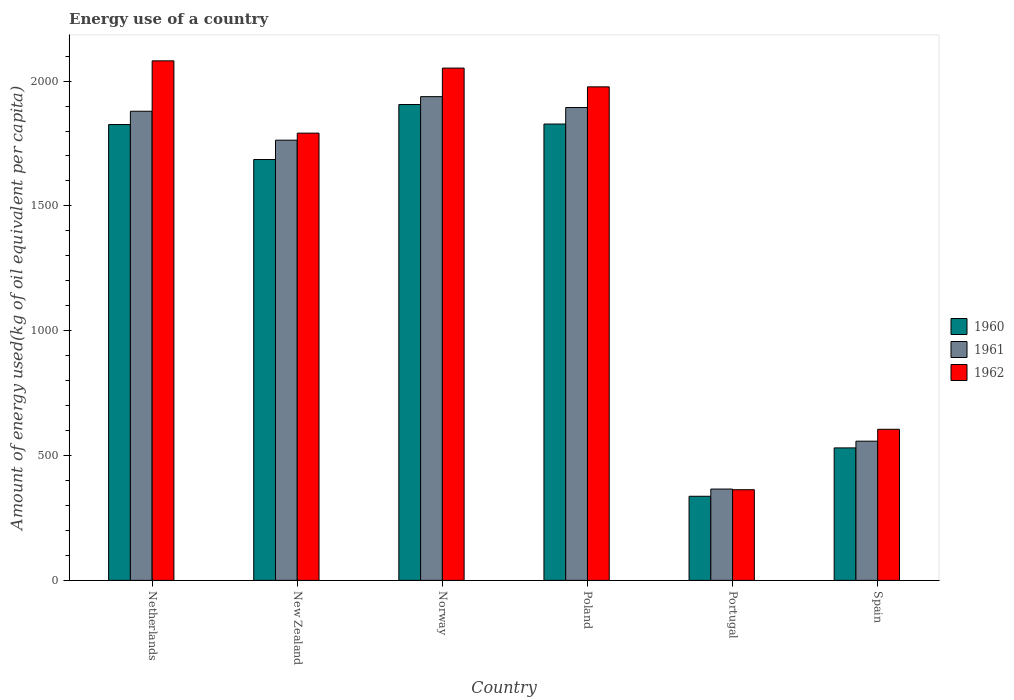Are the number of bars on each tick of the X-axis equal?
Your answer should be compact. Yes. How many bars are there on the 4th tick from the left?
Your response must be concise. 3. How many bars are there on the 1st tick from the right?
Offer a terse response. 3. What is the label of the 6th group of bars from the left?
Your answer should be very brief. Spain. What is the amount of energy used in in 1961 in Norway?
Keep it short and to the point. 1937.64. Across all countries, what is the maximum amount of energy used in in 1962?
Your answer should be compact. 2081.01. Across all countries, what is the minimum amount of energy used in in 1961?
Give a very brief answer. 365.84. In which country was the amount of energy used in in 1961 maximum?
Provide a succinct answer. Norway. In which country was the amount of energy used in in 1962 minimum?
Provide a short and direct response. Portugal. What is the total amount of energy used in in 1960 in the graph?
Offer a very short reply. 8113.41. What is the difference between the amount of energy used in in 1961 in New Zealand and that in Norway?
Provide a short and direct response. -174.38. What is the difference between the amount of energy used in in 1962 in New Zealand and the amount of energy used in in 1961 in Portugal?
Offer a very short reply. 1425.62. What is the average amount of energy used in in 1962 per country?
Make the answer very short. 1478.3. What is the difference between the amount of energy used in of/in 1962 and amount of energy used in of/in 1960 in Norway?
Offer a very short reply. 145.88. What is the ratio of the amount of energy used in in 1960 in New Zealand to that in Spain?
Offer a terse response. 3.18. Is the amount of energy used in in 1961 in Portugal less than that in Spain?
Your answer should be compact. Yes. Is the difference between the amount of energy used in in 1962 in Netherlands and Norway greater than the difference between the amount of energy used in in 1960 in Netherlands and Norway?
Provide a succinct answer. Yes. What is the difference between the highest and the second highest amount of energy used in in 1962?
Give a very brief answer. -104.15. What is the difference between the highest and the lowest amount of energy used in in 1962?
Provide a short and direct response. 1717.85. What does the 2nd bar from the right in Spain represents?
Your answer should be compact. 1961. Is it the case that in every country, the sum of the amount of energy used in in 1962 and amount of energy used in in 1961 is greater than the amount of energy used in in 1960?
Make the answer very short. Yes. What is the difference between two consecutive major ticks on the Y-axis?
Keep it short and to the point. 500. Does the graph contain any zero values?
Your answer should be very brief. No. How many legend labels are there?
Your response must be concise. 3. What is the title of the graph?
Provide a short and direct response. Energy use of a country. Does "1987" appear as one of the legend labels in the graph?
Keep it short and to the point. No. What is the label or title of the X-axis?
Make the answer very short. Country. What is the label or title of the Y-axis?
Your answer should be compact. Amount of energy used(kg of oil equivalent per capita). What is the Amount of energy used(kg of oil equivalent per capita) in 1960 in Netherlands?
Keep it short and to the point. 1825.93. What is the Amount of energy used(kg of oil equivalent per capita) in 1961 in Netherlands?
Offer a very short reply. 1879.15. What is the Amount of energy used(kg of oil equivalent per capita) in 1962 in Netherlands?
Provide a succinct answer. 2081.01. What is the Amount of energy used(kg of oil equivalent per capita) in 1960 in New Zealand?
Provide a succinct answer. 1685.79. What is the Amount of energy used(kg of oil equivalent per capita) of 1961 in New Zealand?
Provide a succinct answer. 1763.26. What is the Amount of energy used(kg of oil equivalent per capita) in 1962 in New Zealand?
Provide a short and direct response. 1791.46. What is the Amount of energy used(kg of oil equivalent per capita) of 1960 in Norway?
Ensure brevity in your answer.  1906.17. What is the Amount of energy used(kg of oil equivalent per capita) in 1961 in Norway?
Ensure brevity in your answer.  1937.64. What is the Amount of energy used(kg of oil equivalent per capita) in 1962 in Norway?
Your answer should be very brief. 2052.05. What is the Amount of energy used(kg of oil equivalent per capita) in 1960 in Poland?
Provide a short and direct response. 1827.94. What is the Amount of energy used(kg of oil equivalent per capita) of 1961 in Poland?
Ensure brevity in your answer.  1894.06. What is the Amount of energy used(kg of oil equivalent per capita) in 1962 in Poland?
Offer a terse response. 1976.86. What is the Amount of energy used(kg of oil equivalent per capita) in 1960 in Portugal?
Provide a short and direct response. 336.91. What is the Amount of energy used(kg of oil equivalent per capita) of 1961 in Portugal?
Your answer should be very brief. 365.84. What is the Amount of energy used(kg of oil equivalent per capita) of 1962 in Portugal?
Make the answer very short. 363.16. What is the Amount of energy used(kg of oil equivalent per capita) of 1960 in Spain?
Give a very brief answer. 530.66. What is the Amount of energy used(kg of oil equivalent per capita) in 1961 in Spain?
Offer a terse response. 557.6. What is the Amount of energy used(kg of oil equivalent per capita) in 1962 in Spain?
Your answer should be very brief. 605.22. Across all countries, what is the maximum Amount of energy used(kg of oil equivalent per capita) in 1960?
Offer a terse response. 1906.17. Across all countries, what is the maximum Amount of energy used(kg of oil equivalent per capita) in 1961?
Ensure brevity in your answer.  1937.64. Across all countries, what is the maximum Amount of energy used(kg of oil equivalent per capita) in 1962?
Make the answer very short. 2081.01. Across all countries, what is the minimum Amount of energy used(kg of oil equivalent per capita) in 1960?
Make the answer very short. 336.91. Across all countries, what is the minimum Amount of energy used(kg of oil equivalent per capita) in 1961?
Give a very brief answer. 365.84. Across all countries, what is the minimum Amount of energy used(kg of oil equivalent per capita) of 1962?
Give a very brief answer. 363.16. What is the total Amount of energy used(kg of oil equivalent per capita) of 1960 in the graph?
Offer a very short reply. 8113.41. What is the total Amount of energy used(kg of oil equivalent per capita) of 1961 in the graph?
Provide a succinct answer. 8397.55. What is the total Amount of energy used(kg of oil equivalent per capita) in 1962 in the graph?
Provide a short and direct response. 8869.77. What is the difference between the Amount of energy used(kg of oil equivalent per capita) of 1960 in Netherlands and that in New Zealand?
Offer a very short reply. 140.15. What is the difference between the Amount of energy used(kg of oil equivalent per capita) of 1961 in Netherlands and that in New Zealand?
Provide a succinct answer. 115.89. What is the difference between the Amount of energy used(kg of oil equivalent per capita) of 1962 in Netherlands and that in New Zealand?
Your answer should be compact. 289.55. What is the difference between the Amount of energy used(kg of oil equivalent per capita) in 1960 in Netherlands and that in Norway?
Provide a short and direct response. -80.24. What is the difference between the Amount of energy used(kg of oil equivalent per capita) of 1961 in Netherlands and that in Norway?
Provide a succinct answer. -58.49. What is the difference between the Amount of energy used(kg of oil equivalent per capita) in 1962 in Netherlands and that in Norway?
Your response must be concise. 28.96. What is the difference between the Amount of energy used(kg of oil equivalent per capita) of 1960 in Netherlands and that in Poland?
Ensure brevity in your answer.  -2. What is the difference between the Amount of energy used(kg of oil equivalent per capita) of 1961 in Netherlands and that in Poland?
Your response must be concise. -14.91. What is the difference between the Amount of energy used(kg of oil equivalent per capita) of 1962 in Netherlands and that in Poland?
Offer a very short reply. 104.15. What is the difference between the Amount of energy used(kg of oil equivalent per capita) of 1960 in Netherlands and that in Portugal?
Keep it short and to the point. 1489.02. What is the difference between the Amount of energy used(kg of oil equivalent per capita) of 1961 in Netherlands and that in Portugal?
Make the answer very short. 1513.31. What is the difference between the Amount of energy used(kg of oil equivalent per capita) in 1962 in Netherlands and that in Portugal?
Ensure brevity in your answer.  1717.85. What is the difference between the Amount of energy used(kg of oil equivalent per capita) in 1960 in Netherlands and that in Spain?
Offer a terse response. 1295.27. What is the difference between the Amount of energy used(kg of oil equivalent per capita) of 1961 in Netherlands and that in Spain?
Your response must be concise. 1321.55. What is the difference between the Amount of energy used(kg of oil equivalent per capita) of 1962 in Netherlands and that in Spain?
Make the answer very short. 1475.79. What is the difference between the Amount of energy used(kg of oil equivalent per capita) of 1960 in New Zealand and that in Norway?
Make the answer very short. -220.39. What is the difference between the Amount of energy used(kg of oil equivalent per capita) of 1961 in New Zealand and that in Norway?
Give a very brief answer. -174.38. What is the difference between the Amount of energy used(kg of oil equivalent per capita) of 1962 in New Zealand and that in Norway?
Ensure brevity in your answer.  -260.59. What is the difference between the Amount of energy used(kg of oil equivalent per capita) in 1960 in New Zealand and that in Poland?
Provide a short and direct response. -142.15. What is the difference between the Amount of energy used(kg of oil equivalent per capita) in 1961 in New Zealand and that in Poland?
Provide a short and direct response. -130.8. What is the difference between the Amount of energy used(kg of oil equivalent per capita) of 1962 in New Zealand and that in Poland?
Make the answer very short. -185.4. What is the difference between the Amount of energy used(kg of oil equivalent per capita) of 1960 in New Zealand and that in Portugal?
Keep it short and to the point. 1348.87. What is the difference between the Amount of energy used(kg of oil equivalent per capita) in 1961 in New Zealand and that in Portugal?
Give a very brief answer. 1397.42. What is the difference between the Amount of energy used(kg of oil equivalent per capita) of 1962 in New Zealand and that in Portugal?
Ensure brevity in your answer.  1428.3. What is the difference between the Amount of energy used(kg of oil equivalent per capita) of 1960 in New Zealand and that in Spain?
Offer a terse response. 1155.12. What is the difference between the Amount of energy used(kg of oil equivalent per capita) of 1961 in New Zealand and that in Spain?
Provide a short and direct response. 1205.66. What is the difference between the Amount of energy used(kg of oil equivalent per capita) of 1962 in New Zealand and that in Spain?
Your response must be concise. 1186.24. What is the difference between the Amount of energy used(kg of oil equivalent per capita) in 1960 in Norway and that in Poland?
Ensure brevity in your answer.  78.24. What is the difference between the Amount of energy used(kg of oil equivalent per capita) in 1961 in Norway and that in Poland?
Provide a succinct answer. 43.59. What is the difference between the Amount of energy used(kg of oil equivalent per capita) in 1962 in Norway and that in Poland?
Give a very brief answer. 75.19. What is the difference between the Amount of energy used(kg of oil equivalent per capita) of 1960 in Norway and that in Portugal?
Offer a very short reply. 1569.26. What is the difference between the Amount of energy used(kg of oil equivalent per capita) of 1961 in Norway and that in Portugal?
Provide a succinct answer. 1571.8. What is the difference between the Amount of energy used(kg of oil equivalent per capita) in 1962 in Norway and that in Portugal?
Provide a short and direct response. 1688.89. What is the difference between the Amount of energy used(kg of oil equivalent per capita) in 1960 in Norway and that in Spain?
Make the answer very short. 1375.51. What is the difference between the Amount of energy used(kg of oil equivalent per capita) in 1961 in Norway and that in Spain?
Offer a very short reply. 1380.05. What is the difference between the Amount of energy used(kg of oil equivalent per capita) of 1962 in Norway and that in Spain?
Your answer should be very brief. 1446.83. What is the difference between the Amount of energy used(kg of oil equivalent per capita) in 1960 in Poland and that in Portugal?
Provide a short and direct response. 1491.02. What is the difference between the Amount of energy used(kg of oil equivalent per capita) in 1961 in Poland and that in Portugal?
Your answer should be very brief. 1528.22. What is the difference between the Amount of energy used(kg of oil equivalent per capita) of 1962 in Poland and that in Portugal?
Give a very brief answer. 1613.7. What is the difference between the Amount of energy used(kg of oil equivalent per capita) of 1960 in Poland and that in Spain?
Provide a short and direct response. 1297.27. What is the difference between the Amount of energy used(kg of oil equivalent per capita) in 1961 in Poland and that in Spain?
Provide a short and direct response. 1336.46. What is the difference between the Amount of energy used(kg of oil equivalent per capita) of 1962 in Poland and that in Spain?
Provide a succinct answer. 1371.64. What is the difference between the Amount of energy used(kg of oil equivalent per capita) of 1960 in Portugal and that in Spain?
Your response must be concise. -193.75. What is the difference between the Amount of energy used(kg of oil equivalent per capita) of 1961 in Portugal and that in Spain?
Your answer should be compact. -191.76. What is the difference between the Amount of energy used(kg of oil equivalent per capita) in 1962 in Portugal and that in Spain?
Keep it short and to the point. -242.06. What is the difference between the Amount of energy used(kg of oil equivalent per capita) of 1960 in Netherlands and the Amount of energy used(kg of oil equivalent per capita) of 1961 in New Zealand?
Keep it short and to the point. 62.67. What is the difference between the Amount of energy used(kg of oil equivalent per capita) of 1960 in Netherlands and the Amount of energy used(kg of oil equivalent per capita) of 1962 in New Zealand?
Your answer should be very brief. 34.47. What is the difference between the Amount of energy used(kg of oil equivalent per capita) in 1961 in Netherlands and the Amount of energy used(kg of oil equivalent per capita) in 1962 in New Zealand?
Offer a terse response. 87.69. What is the difference between the Amount of energy used(kg of oil equivalent per capita) of 1960 in Netherlands and the Amount of energy used(kg of oil equivalent per capita) of 1961 in Norway?
Give a very brief answer. -111.71. What is the difference between the Amount of energy used(kg of oil equivalent per capita) in 1960 in Netherlands and the Amount of energy used(kg of oil equivalent per capita) in 1962 in Norway?
Ensure brevity in your answer.  -226.12. What is the difference between the Amount of energy used(kg of oil equivalent per capita) in 1961 in Netherlands and the Amount of energy used(kg of oil equivalent per capita) in 1962 in Norway?
Your response must be concise. -172.9. What is the difference between the Amount of energy used(kg of oil equivalent per capita) of 1960 in Netherlands and the Amount of energy used(kg of oil equivalent per capita) of 1961 in Poland?
Provide a succinct answer. -68.12. What is the difference between the Amount of energy used(kg of oil equivalent per capita) of 1960 in Netherlands and the Amount of energy used(kg of oil equivalent per capita) of 1962 in Poland?
Make the answer very short. -150.93. What is the difference between the Amount of energy used(kg of oil equivalent per capita) in 1961 in Netherlands and the Amount of energy used(kg of oil equivalent per capita) in 1962 in Poland?
Your answer should be very brief. -97.71. What is the difference between the Amount of energy used(kg of oil equivalent per capita) of 1960 in Netherlands and the Amount of energy used(kg of oil equivalent per capita) of 1961 in Portugal?
Keep it short and to the point. 1460.09. What is the difference between the Amount of energy used(kg of oil equivalent per capita) of 1960 in Netherlands and the Amount of energy used(kg of oil equivalent per capita) of 1962 in Portugal?
Provide a succinct answer. 1462.77. What is the difference between the Amount of energy used(kg of oil equivalent per capita) of 1961 in Netherlands and the Amount of energy used(kg of oil equivalent per capita) of 1962 in Portugal?
Your answer should be compact. 1515.99. What is the difference between the Amount of energy used(kg of oil equivalent per capita) in 1960 in Netherlands and the Amount of energy used(kg of oil equivalent per capita) in 1961 in Spain?
Ensure brevity in your answer.  1268.34. What is the difference between the Amount of energy used(kg of oil equivalent per capita) in 1960 in Netherlands and the Amount of energy used(kg of oil equivalent per capita) in 1962 in Spain?
Make the answer very short. 1220.71. What is the difference between the Amount of energy used(kg of oil equivalent per capita) in 1961 in Netherlands and the Amount of energy used(kg of oil equivalent per capita) in 1962 in Spain?
Provide a short and direct response. 1273.93. What is the difference between the Amount of energy used(kg of oil equivalent per capita) of 1960 in New Zealand and the Amount of energy used(kg of oil equivalent per capita) of 1961 in Norway?
Your answer should be very brief. -251.86. What is the difference between the Amount of energy used(kg of oil equivalent per capita) of 1960 in New Zealand and the Amount of energy used(kg of oil equivalent per capita) of 1962 in Norway?
Your answer should be compact. -366.27. What is the difference between the Amount of energy used(kg of oil equivalent per capita) in 1961 in New Zealand and the Amount of energy used(kg of oil equivalent per capita) in 1962 in Norway?
Your answer should be compact. -288.79. What is the difference between the Amount of energy used(kg of oil equivalent per capita) of 1960 in New Zealand and the Amount of energy used(kg of oil equivalent per capita) of 1961 in Poland?
Your answer should be compact. -208.27. What is the difference between the Amount of energy used(kg of oil equivalent per capita) of 1960 in New Zealand and the Amount of energy used(kg of oil equivalent per capita) of 1962 in Poland?
Ensure brevity in your answer.  -291.07. What is the difference between the Amount of energy used(kg of oil equivalent per capita) of 1961 in New Zealand and the Amount of energy used(kg of oil equivalent per capita) of 1962 in Poland?
Offer a very short reply. -213.6. What is the difference between the Amount of energy used(kg of oil equivalent per capita) of 1960 in New Zealand and the Amount of energy used(kg of oil equivalent per capita) of 1961 in Portugal?
Your response must be concise. 1319.95. What is the difference between the Amount of energy used(kg of oil equivalent per capita) of 1960 in New Zealand and the Amount of energy used(kg of oil equivalent per capita) of 1962 in Portugal?
Make the answer very short. 1322.62. What is the difference between the Amount of energy used(kg of oil equivalent per capita) of 1961 in New Zealand and the Amount of energy used(kg of oil equivalent per capita) of 1962 in Portugal?
Offer a very short reply. 1400.1. What is the difference between the Amount of energy used(kg of oil equivalent per capita) of 1960 in New Zealand and the Amount of energy used(kg of oil equivalent per capita) of 1961 in Spain?
Your answer should be very brief. 1128.19. What is the difference between the Amount of energy used(kg of oil equivalent per capita) of 1960 in New Zealand and the Amount of energy used(kg of oil equivalent per capita) of 1962 in Spain?
Your answer should be very brief. 1080.56. What is the difference between the Amount of energy used(kg of oil equivalent per capita) in 1961 in New Zealand and the Amount of energy used(kg of oil equivalent per capita) in 1962 in Spain?
Provide a short and direct response. 1158.04. What is the difference between the Amount of energy used(kg of oil equivalent per capita) of 1960 in Norway and the Amount of energy used(kg of oil equivalent per capita) of 1961 in Poland?
Give a very brief answer. 12.12. What is the difference between the Amount of energy used(kg of oil equivalent per capita) of 1960 in Norway and the Amount of energy used(kg of oil equivalent per capita) of 1962 in Poland?
Give a very brief answer. -70.68. What is the difference between the Amount of energy used(kg of oil equivalent per capita) in 1961 in Norway and the Amount of energy used(kg of oil equivalent per capita) in 1962 in Poland?
Provide a short and direct response. -39.22. What is the difference between the Amount of energy used(kg of oil equivalent per capita) in 1960 in Norway and the Amount of energy used(kg of oil equivalent per capita) in 1961 in Portugal?
Offer a very short reply. 1540.33. What is the difference between the Amount of energy used(kg of oil equivalent per capita) of 1960 in Norway and the Amount of energy used(kg of oil equivalent per capita) of 1962 in Portugal?
Keep it short and to the point. 1543.01. What is the difference between the Amount of energy used(kg of oil equivalent per capita) of 1961 in Norway and the Amount of energy used(kg of oil equivalent per capita) of 1962 in Portugal?
Provide a short and direct response. 1574.48. What is the difference between the Amount of energy used(kg of oil equivalent per capita) of 1960 in Norway and the Amount of energy used(kg of oil equivalent per capita) of 1961 in Spain?
Your answer should be compact. 1348.58. What is the difference between the Amount of energy used(kg of oil equivalent per capita) in 1960 in Norway and the Amount of energy used(kg of oil equivalent per capita) in 1962 in Spain?
Keep it short and to the point. 1300.95. What is the difference between the Amount of energy used(kg of oil equivalent per capita) in 1961 in Norway and the Amount of energy used(kg of oil equivalent per capita) in 1962 in Spain?
Give a very brief answer. 1332.42. What is the difference between the Amount of energy used(kg of oil equivalent per capita) in 1960 in Poland and the Amount of energy used(kg of oil equivalent per capita) in 1961 in Portugal?
Provide a short and direct response. 1462.1. What is the difference between the Amount of energy used(kg of oil equivalent per capita) in 1960 in Poland and the Amount of energy used(kg of oil equivalent per capita) in 1962 in Portugal?
Offer a very short reply. 1464.77. What is the difference between the Amount of energy used(kg of oil equivalent per capita) of 1961 in Poland and the Amount of energy used(kg of oil equivalent per capita) of 1962 in Portugal?
Provide a succinct answer. 1530.89. What is the difference between the Amount of energy used(kg of oil equivalent per capita) of 1960 in Poland and the Amount of energy used(kg of oil equivalent per capita) of 1961 in Spain?
Offer a terse response. 1270.34. What is the difference between the Amount of energy used(kg of oil equivalent per capita) in 1960 in Poland and the Amount of energy used(kg of oil equivalent per capita) in 1962 in Spain?
Your answer should be compact. 1222.71. What is the difference between the Amount of energy used(kg of oil equivalent per capita) of 1961 in Poland and the Amount of energy used(kg of oil equivalent per capita) of 1962 in Spain?
Your response must be concise. 1288.83. What is the difference between the Amount of energy used(kg of oil equivalent per capita) in 1960 in Portugal and the Amount of energy used(kg of oil equivalent per capita) in 1961 in Spain?
Ensure brevity in your answer.  -220.69. What is the difference between the Amount of energy used(kg of oil equivalent per capita) in 1960 in Portugal and the Amount of energy used(kg of oil equivalent per capita) in 1962 in Spain?
Provide a short and direct response. -268.31. What is the difference between the Amount of energy used(kg of oil equivalent per capita) of 1961 in Portugal and the Amount of energy used(kg of oil equivalent per capita) of 1962 in Spain?
Ensure brevity in your answer.  -239.38. What is the average Amount of energy used(kg of oil equivalent per capita) in 1960 per country?
Keep it short and to the point. 1352.24. What is the average Amount of energy used(kg of oil equivalent per capita) in 1961 per country?
Your answer should be very brief. 1399.59. What is the average Amount of energy used(kg of oil equivalent per capita) of 1962 per country?
Provide a succinct answer. 1478.3. What is the difference between the Amount of energy used(kg of oil equivalent per capita) of 1960 and Amount of energy used(kg of oil equivalent per capita) of 1961 in Netherlands?
Give a very brief answer. -53.22. What is the difference between the Amount of energy used(kg of oil equivalent per capita) of 1960 and Amount of energy used(kg of oil equivalent per capita) of 1962 in Netherlands?
Give a very brief answer. -255.08. What is the difference between the Amount of energy used(kg of oil equivalent per capita) in 1961 and Amount of energy used(kg of oil equivalent per capita) in 1962 in Netherlands?
Provide a short and direct response. -201.86. What is the difference between the Amount of energy used(kg of oil equivalent per capita) in 1960 and Amount of energy used(kg of oil equivalent per capita) in 1961 in New Zealand?
Give a very brief answer. -77.47. What is the difference between the Amount of energy used(kg of oil equivalent per capita) of 1960 and Amount of energy used(kg of oil equivalent per capita) of 1962 in New Zealand?
Your response must be concise. -105.67. What is the difference between the Amount of energy used(kg of oil equivalent per capita) in 1961 and Amount of energy used(kg of oil equivalent per capita) in 1962 in New Zealand?
Give a very brief answer. -28.2. What is the difference between the Amount of energy used(kg of oil equivalent per capita) of 1960 and Amount of energy used(kg of oil equivalent per capita) of 1961 in Norway?
Keep it short and to the point. -31.47. What is the difference between the Amount of energy used(kg of oil equivalent per capita) in 1960 and Amount of energy used(kg of oil equivalent per capita) in 1962 in Norway?
Give a very brief answer. -145.88. What is the difference between the Amount of energy used(kg of oil equivalent per capita) of 1961 and Amount of energy used(kg of oil equivalent per capita) of 1962 in Norway?
Your response must be concise. -114.41. What is the difference between the Amount of energy used(kg of oil equivalent per capita) of 1960 and Amount of energy used(kg of oil equivalent per capita) of 1961 in Poland?
Your answer should be very brief. -66.12. What is the difference between the Amount of energy used(kg of oil equivalent per capita) of 1960 and Amount of energy used(kg of oil equivalent per capita) of 1962 in Poland?
Offer a terse response. -148.92. What is the difference between the Amount of energy used(kg of oil equivalent per capita) in 1961 and Amount of energy used(kg of oil equivalent per capita) in 1962 in Poland?
Your answer should be compact. -82.8. What is the difference between the Amount of energy used(kg of oil equivalent per capita) of 1960 and Amount of energy used(kg of oil equivalent per capita) of 1961 in Portugal?
Keep it short and to the point. -28.93. What is the difference between the Amount of energy used(kg of oil equivalent per capita) in 1960 and Amount of energy used(kg of oil equivalent per capita) in 1962 in Portugal?
Provide a succinct answer. -26.25. What is the difference between the Amount of energy used(kg of oil equivalent per capita) of 1961 and Amount of energy used(kg of oil equivalent per capita) of 1962 in Portugal?
Provide a succinct answer. 2.68. What is the difference between the Amount of energy used(kg of oil equivalent per capita) of 1960 and Amount of energy used(kg of oil equivalent per capita) of 1961 in Spain?
Make the answer very short. -26.93. What is the difference between the Amount of energy used(kg of oil equivalent per capita) in 1960 and Amount of energy used(kg of oil equivalent per capita) in 1962 in Spain?
Your response must be concise. -74.56. What is the difference between the Amount of energy used(kg of oil equivalent per capita) of 1961 and Amount of energy used(kg of oil equivalent per capita) of 1962 in Spain?
Your answer should be very brief. -47.62. What is the ratio of the Amount of energy used(kg of oil equivalent per capita) in 1960 in Netherlands to that in New Zealand?
Offer a terse response. 1.08. What is the ratio of the Amount of energy used(kg of oil equivalent per capita) of 1961 in Netherlands to that in New Zealand?
Your answer should be compact. 1.07. What is the ratio of the Amount of energy used(kg of oil equivalent per capita) of 1962 in Netherlands to that in New Zealand?
Offer a very short reply. 1.16. What is the ratio of the Amount of energy used(kg of oil equivalent per capita) in 1960 in Netherlands to that in Norway?
Offer a very short reply. 0.96. What is the ratio of the Amount of energy used(kg of oil equivalent per capita) of 1961 in Netherlands to that in Norway?
Offer a very short reply. 0.97. What is the ratio of the Amount of energy used(kg of oil equivalent per capita) in 1962 in Netherlands to that in Norway?
Provide a short and direct response. 1.01. What is the ratio of the Amount of energy used(kg of oil equivalent per capita) of 1962 in Netherlands to that in Poland?
Offer a very short reply. 1.05. What is the ratio of the Amount of energy used(kg of oil equivalent per capita) in 1960 in Netherlands to that in Portugal?
Your response must be concise. 5.42. What is the ratio of the Amount of energy used(kg of oil equivalent per capita) in 1961 in Netherlands to that in Portugal?
Offer a terse response. 5.14. What is the ratio of the Amount of energy used(kg of oil equivalent per capita) of 1962 in Netherlands to that in Portugal?
Your answer should be very brief. 5.73. What is the ratio of the Amount of energy used(kg of oil equivalent per capita) of 1960 in Netherlands to that in Spain?
Your response must be concise. 3.44. What is the ratio of the Amount of energy used(kg of oil equivalent per capita) of 1961 in Netherlands to that in Spain?
Your answer should be very brief. 3.37. What is the ratio of the Amount of energy used(kg of oil equivalent per capita) of 1962 in Netherlands to that in Spain?
Your response must be concise. 3.44. What is the ratio of the Amount of energy used(kg of oil equivalent per capita) in 1960 in New Zealand to that in Norway?
Your answer should be compact. 0.88. What is the ratio of the Amount of energy used(kg of oil equivalent per capita) in 1961 in New Zealand to that in Norway?
Offer a terse response. 0.91. What is the ratio of the Amount of energy used(kg of oil equivalent per capita) in 1962 in New Zealand to that in Norway?
Your answer should be compact. 0.87. What is the ratio of the Amount of energy used(kg of oil equivalent per capita) of 1960 in New Zealand to that in Poland?
Your answer should be compact. 0.92. What is the ratio of the Amount of energy used(kg of oil equivalent per capita) in 1961 in New Zealand to that in Poland?
Offer a very short reply. 0.93. What is the ratio of the Amount of energy used(kg of oil equivalent per capita) of 1962 in New Zealand to that in Poland?
Your response must be concise. 0.91. What is the ratio of the Amount of energy used(kg of oil equivalent per capita) of 1960 in New Zealand to that in Portugal?
Provide a short and direct response. 5. What is the ratio of the Amount of energy used(kg of oil equivalent per capita) in 1961 in New Zealand to that in Portugal?
Your answer should be very brief. 4.82. What is the ratio of the Amount of energy used(kg of oil equivalent per capita) of 1962 in New Zealand to that in Portugal?
Your answer should be compact. 4.93. What is the ratio of the Amount of energy used(kg of oil equivalent per capita) of 1960 in New Zealand to that in Spain?
Provide a short and direct response. 3.18. What is the ratio of the Amount of energy used(kg of oil equivalent per capita) in 1961 in New Zealand to that in Spain?
Your answer should be very brief. 3.16. What is the ratio of the Amount of energy used(kg of oil equivalent per capita) in 1962 in New Zealand to that in Spain?
Offer a very short reply. 2.96. What is the ratio of the Amount of energy used(kg of oil equivalent per capita) of 1960 in Norway to that in Poland?
Offer a terse response. 1.04. What is the ratio of the Amount of energy used(kg of oil equivalent per capita) in 1961 in Norway to that in Poland?
Keep it short and to the point. 1.02. What is the ratio of the Amount of energy used(kg of oil equivalent per capita) in 1962 in Norway to that in Poland?
Provide a short and direct response. 1.04. What is the ratio of the Amount of energy used(kg of oil equivalent per capita) in 1960 in Norway to that in Portugal?
Offer a very short reply. 5.66. What is the ratio of the Amount of energy used(kg of oil equivalent per capita) in 1961 in Norway to that in Portugal?
Offer a terse response. 5.3. What is the ratio of the Amount of energy used(kg of oil equivalent per capita) in 1962 in Norway to that in Portugal?
Offer a very short reply. 5.65. What is the ratio of the Amount of energy used(kg of oil equivalent per capita) in 1960 in Norway to that in Spain?
Offer a terse response. 3.59. What is the ratio of the Amount of energy used(kg of oil equivalent per capita) of 1961 in Norway to that in Spain?
Provide a short and direct response. 3.48. What is the ratio of the Amount of energy used(kg of oil equivalent per capita) of 1962 in Norway to that in Spain?
Give a very brief answer. 3.39. What is the ratio of the Amount of energy used(kg of oil equivalent per capita) in 1960 in Poland to that in Portugal?
Your response must be concise. 5.43. What is the ratio of the Amount of energy used(kg of oil equivalent per capita) in 1961 in Poland to that in Portugal?
Keep it short and to the point. 5.18. What is the ratio of the Amount of energy used(kg of oil equivalent per capita) of 1962 in Poland to that in Portugal?
Offer a terse response. 5.44. What is the ratio of the Amount of energy used(kg of oil equivalent per capita) in 1960 in Poland to that in Spain?
Provide a short and direct response. 3.44. What is the ratio of the Amount of energy used(kg of oil equivalent per capita) in 1961 in Poland to that in Spain?
Your answer should be compact. 3.4. What is the ratio of the Amount of energy used(kg of oil equivalent per capita) of 1962 in Poland to that in Spain?
Your answer should be compact. 3.27. What is the ratio of the Amount of energy used(kg of oil equivalent per capita) in 1960 in Portugal to that in Spain?
Offer a terse response. 0.63. What is the ratio of the Amount of energy used(kg of oil equivalent per capita) of 1961 in Portugal to that in Spain?
Provide a short and direct response. 0.66. What is the ratio of the Amount of energy used(kg of oil equivalent per capita) in 1962 in Portugal to that in Spain?
Make the answer very short. 0.6. What is the difference between the highest and the second highest Amount of energy used(kg of oil equivalent per capita) in 1960?
Your answer should be very brief. 78.24. What is the difference between the highest and the second highest Amount of energy used(kg of oil equivalent per capita) in 1961?
Ensure brevity in your answer.  43.59. What is the difference between the highest and the second highest Amount of energy used(kg of oil equivalent per capita) in 1962?
Give a very brief answer. 28.96. What is the difference between the highest and the lowest Amount of energy used(kg of oil equivalent per capita) in 1960?
Keep it short and to the point. 1569.26. What is the difference between the highest and the lowest Amount of energy used(kg of oil equivalent per capita) of 1961?
Your response must be concise. 1571.8. What is the difference between the highest and the lowest Amount of energy used(kg of oil equivalent per capita) of 1962?
Your answer should be very brief. 1717.85. 